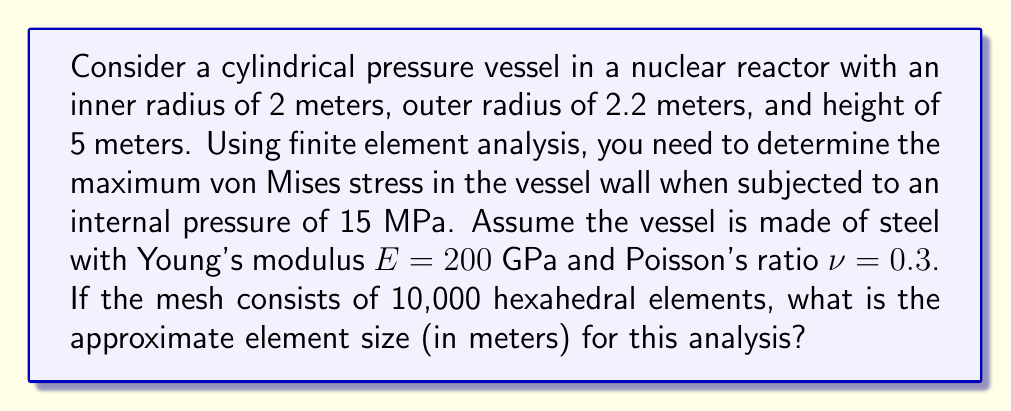Solve this math problem. To solve this problem, we need to follow these steps:

1) First, we need to calculate the volume of the pressure vessel:
   $$V = \pi(r_o^2 - r_i^2)h$$
   where $r_o$ is the outer radius, $r_i$ is the inner radius, and $h$ is the height.

   $$V = \pi((2.2\textrm{ m})^2 - (2\textrm{ m})^2) \cdot 5\textrm{ m} = 6.28\textrm{ m}^3$$

2) Now, we need to determine the volume of each finite element. Since we have 10,000 elements, we can divide the total volume by the number of elements:

   $$V_{element} = \frac{6.28\textrm{ m}^3}{10,000} = 6.28 \times 10^{-4}\textrm{ m}^3$$

3) Assuming the elements are roughly cubic, we can take the cube root of this volume to get the approximate element size:

   $$\textrm{Element size} \approx \sqrt[3]{6.28 \times 10^{-4}\textrm{ m}^3} \approx 0.0857\textrm{ m}$$

4) This element size is appropriate for the scale of the problem, as it's about 4% of the vessel thickness (0.2 m), which should provide reasonable resolution for stress analysis.

Note: In practice, the mesh would likely be non-uniform, with smaller elements in areas of high stress gradients. This calculation provides an average element size for the given number of elements.
Answer: The approximate element size for the finite element analysis is 0.0857 meters. 